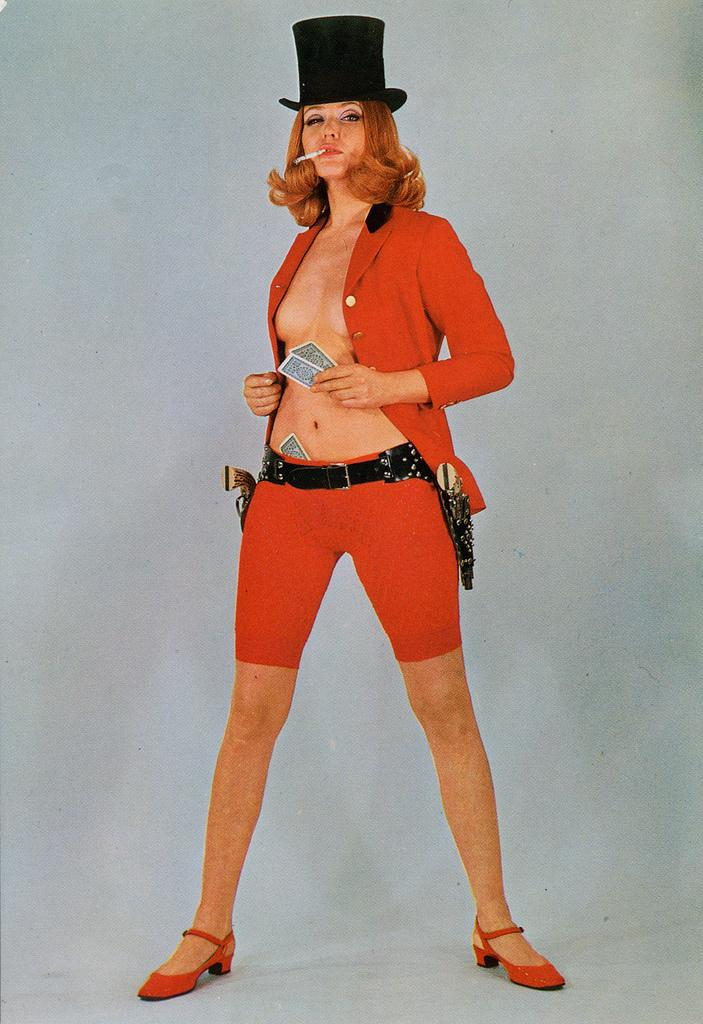Who is present in the image? There is a woman in the image. What is the woman doing in the image? The woman is standing and holding cards. What is the woman doing with her mouth in the image? The woman is smoking. What is the woman wearing on her head in the image? The woman is wearing a hat. What can be seen in the background of the image? There is a wall visible in the background of the image. What type of record can be seen on the wall in the image? There is no record visible on the wall in the image. 